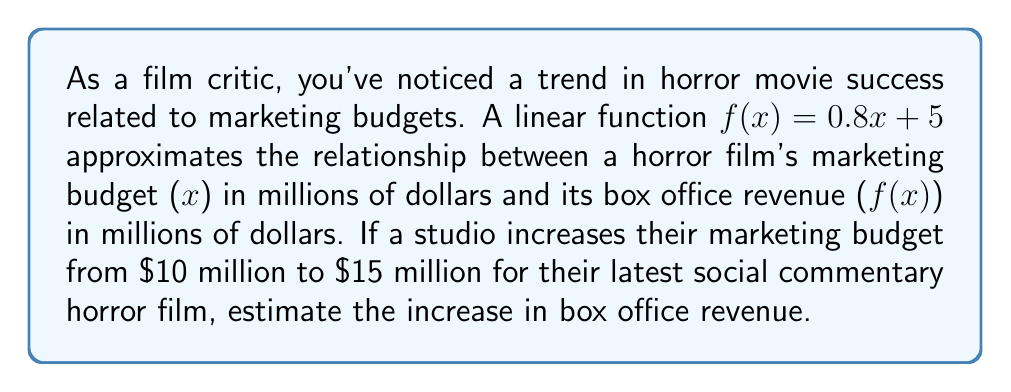Help me with this question. To solve this problem, we'll follow these steps:

1. Calculate the box office revenue for a $10 million marketing budget:
   $f(10) = 0.8(10) + 5 = 8 + 5 = 13$ million dollars

2. Calculate the box office revenue for a $15 million marketing budget:
   $f(15) = 0.8(15) + 5 = 12 + 5 = 17$ million dollars

3. Find the difference between the two revenues:
   $17 - 13 = 4$ million dollars

This increase of $4 million in box office revenue represents the estimated impact of increasing the marketing budget from $10 million to $15 million.
Answer: $4 million 